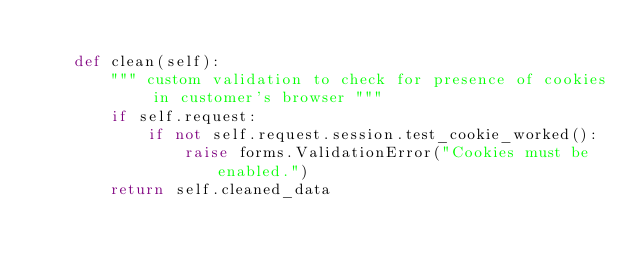Convert code to text. <code><loc_0><loc_0><loc_500><loc_500><_Python_>
    def clean(self):
        """ custom validation to check for presence of cookies in customer's browser """
        if self.request:
            if not self.request.session.test_cookie_worked():
                raise forms.ValidationError("Cookies must be enabled.")
        return self.cleaned_data
</code> 